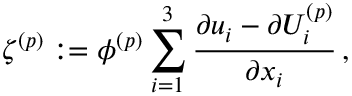<formula> <loc_0><loc_0><loc_500><loc_500>\zeta ^ { ( p ) } \colon = \phi ^ { ( p ) } \sum _ { i = 1 } ^ { 3 } \frac { \partial { u _ { i } } - \partial { U _ { i } ^ { ( p ) } } } { \partial { x _ { i } } } \, ,</formula> 